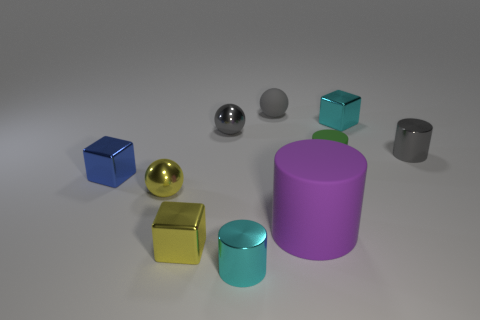What is the color of the small metal cylinder to the right of the cyan metallic cylinder?
Make the answer very short. Gray. What number of other things are the same size as the purple cylinder?
Offer a terse response. 0. What size is the gray object that is both in front of the cyan block and to the left of the small gray cylinder?
Keep it short and to the point. Small. There is a tiny matte cylinder; is it the same color as the small block that is behind the green rubber object?
Give a very brief answer. No. Is there another big gray object that has the same shape as the gray rubber object?
Provide a short and direct response. No. What number of objects are either large rubber balls or small shiny cylinders on the right side of the green matte cylinder?
Your response must be concise. 1. How many other objects are there of the same material as the yellow sphere?
Make the answer very short. 6. How many objects are either tiny yellow shiny spheres or large purple cylinders?
Your answer should be compact. 2. Is the number of tiny green rubber cylinders that are behind the gray cylinder greater than the number of tiny yellow things on the right side of the cyan metallic cylinder?
Offer a terse response. No. Is the color of the metal ball behind the tiny yellow shiny ball the same as the shiny ball that is in front of the tiny blue object?
Your answer should be very brief. No. 